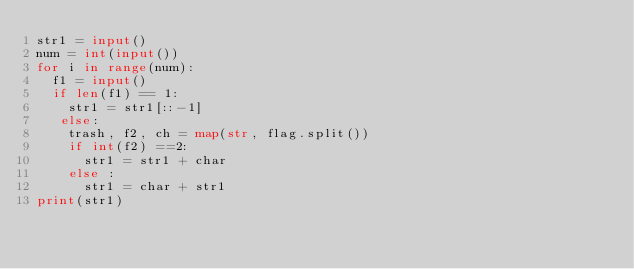<code> <loc_0><loc_0><loc_500><loc_500><_Python_>str1 = input()
num = int(input())
for i in range(num):
  f1 = input()
  if len(f1) == 1:
    str1 = str1[::-1]
   else:
    trash, f2, ch = map(str, flag.split())
    if int(f2) ==2:
      str1 = str1 + char
    else :
      str1 = char + str1
print(str1)</code> 